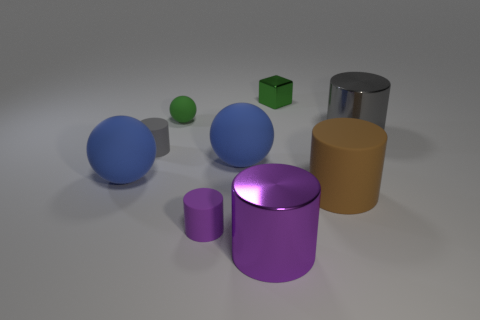Is the tiny metallic cube the same color as the small rubber ball?
Your response must be concise. Yes. Is the size of the green sphere the same as the gray rubber object?
Your answer should be very brief. Yes. What number of gray metal things have the same size as the purple matte cylinder?
Keep it short and to the point. 0. The small shiny thing that is the same color as the tiny ball is what shape?
Provide a succinct answer. Cube. Do the gray cylinder that is on the left side of the large brown matte object and the sphere behind the big gray metallic cylinder have the same material?
Your answer should be compact. Yes. Is there anything else that has the same shape as the tiny green metal object?
Your answer should be very brief. No. What is the color of the tiny rubber ball?
Provide a succinct answer. Green. What number of big metal things are the same shape as the small gray object?
Keep it short and to the point. 2. What color is the rubber cylinder that is the same size as the purple shiny thing?
Your response must be concise. Brown. Is there a big cube?
Keep it short and to the point. No. 